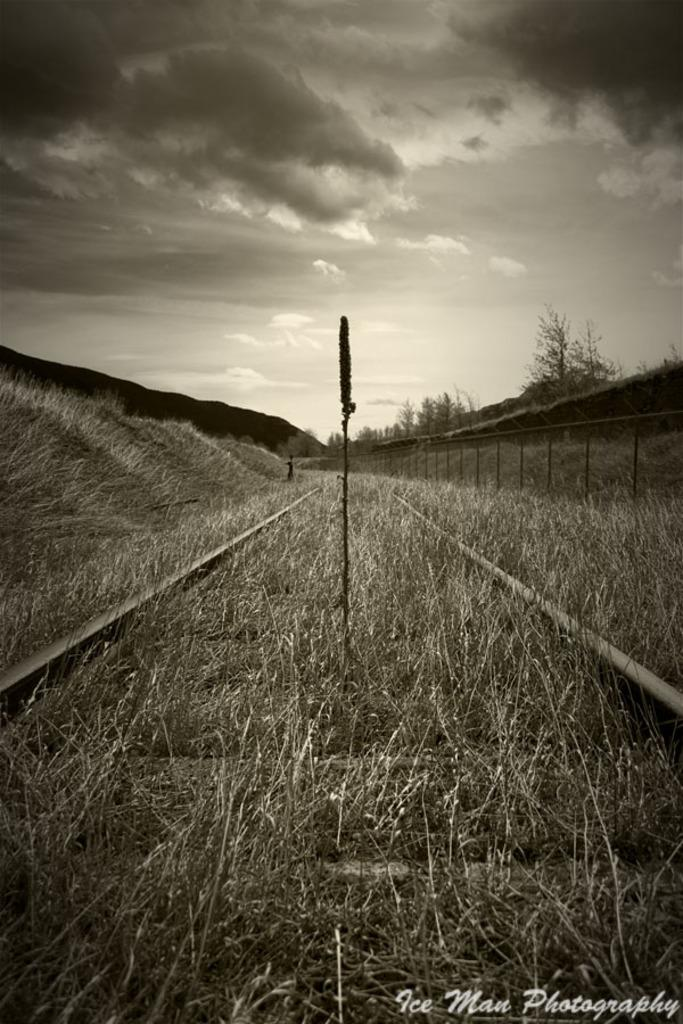What is the main subject of the image? The main subject of the image is a railway track. What can be seen near the railway track? Dry grass is present near the railway track. What is visible in the background of the image? There are trees and the sky visible in the background of the image. What type of soap is being used to clean the trees in the image? There is no soap or cleaning activity present in the image; the trees are simply visible in the background. 